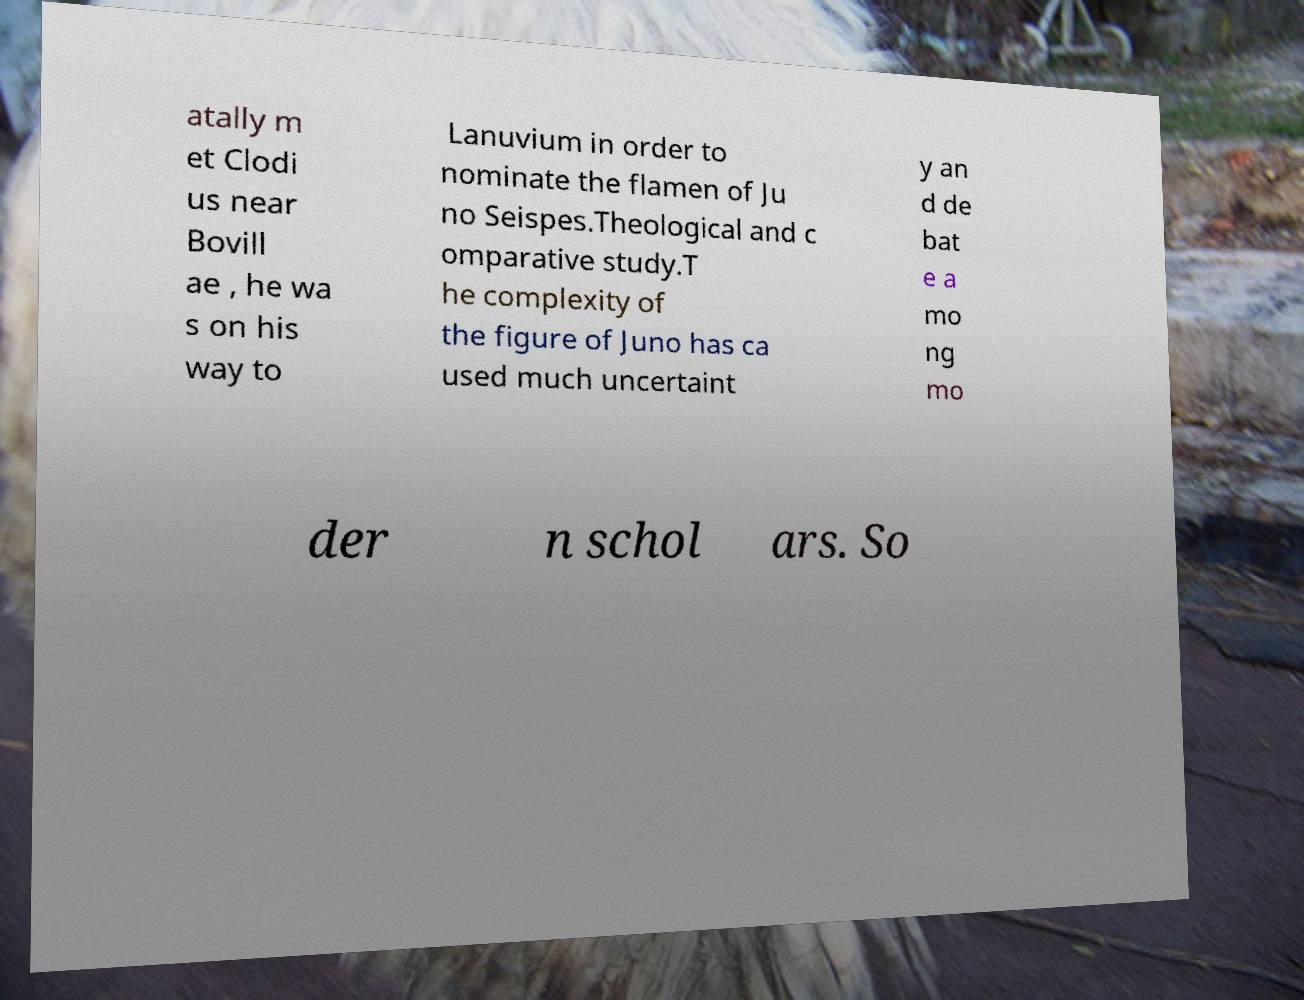What messages or text are displayed in this image? I need them in a readable, typed format. atally m et Clodi us near Bovill ae , he wa s on his way to Lanuvium in order to nominate the flamen of Ju no Seispes.Theological and c omparative study.T he complexity of the figure of Juno has ca used much uncertaint y an d de bat e a mo ng mo der n schol ars. So 